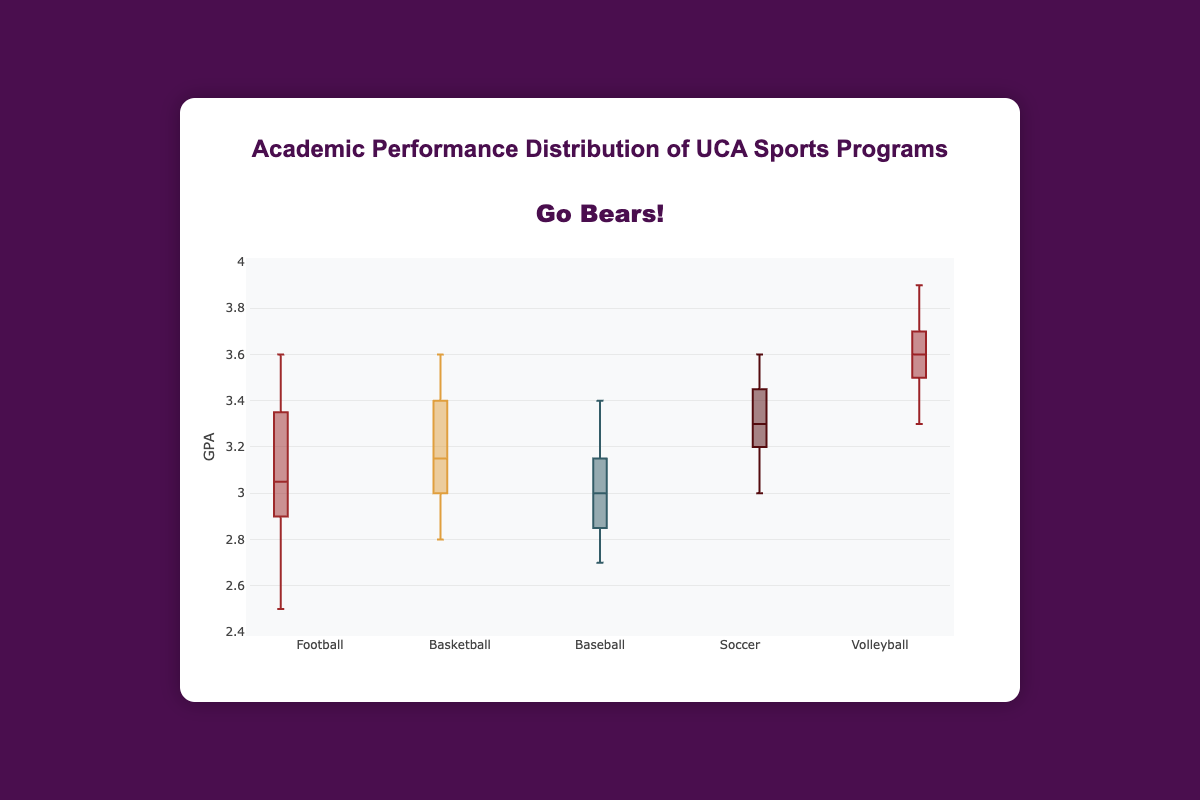What is the title of the plot? The title of the plot is displayed at the top of the figure. By reading it, we can see that it says "Go Bears!" which reflects pride for the Central Arkansas Bears.
Answer: Go Bears! What is the range of the y-axis in the plot? The y-axis, which measures GPA, ranges from 2.4 to 4.0. These values are indicated at both the bottom and top extremes of the y-axis.
Answer: 2.4 to 4.0 Which sports program shows the highest median GPA? The median GPA for each sport is indicated by the line inside each box. By observing the box plots, Volleyball has the highest median GPA.
Answer: Volleyball Which sport has the widest range of GPA values? The range of GPA values for each sport can be seen by looking at the span between the lowest and highest points (whiskers or outliers). Football has the widest range as it extends from around 2.5 to 3.6.
Answer: Football Are there any suspected outliers in the Volleyball GPA distribution? Yes, suspected outliers are indicated by points outside the whiskers of the box plot. For Volleyball, there are none visible in the plot.
Answer: No Which sport has the lowest minimum GPA? The minimum GPA for each sport is indicated by the bottom whisker of the box. Football has the lowest minimum GPA at around 2.5.
Answer: Football How does the third quartile (Q3) of Soccer compare to the median of Basketball? The third quartile (Q3) is the top edge of the box. For Soccer, this Q3 is approximately 3.5, and the median for Basketball is around 3.1. Therefore, Soccer's Q3 is higher than Basketball's median.
Answer: Soccer's Q3 is higher What is the interquartile range (IQR) for Baseball? The IQR is calculated by subtracting the first quartile (Q1) from the third quartile (Q3). For Baseball, the Q3 is around 3.2 and the Q1 is about 2.8, so the IQR is 3.2 - 2.8 = 0.4.
Answer: 0.4 Which sport has the most clustered data (least spread)? By looking at the width of the boxes and the range of the whiskers, Volleyball has the most clustered data as it shows the least variability with a tight interquartile range.
Answer: Volleyball What does the box plot tell us about the academic performance of the Soccer team compared to the Football team? Comparing the box plots of Soccer and Football, Soccer has a higher median GPA and is more centered around a higher range of GPAs. Football has a wider spread with lower minimum values. This indicates that the Soccer team generally performs better academically and more consistently than the Football team.
Answer: Soccer performs better academically and more consistently 